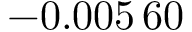<formula> <loc_0><loc_0><loc_500><loc_500>- 0 . 0 0 5 \, 6 0</formula> 